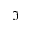<formula> <loc_0><loc_0><loc_500><loc_500>\Im</formula> 